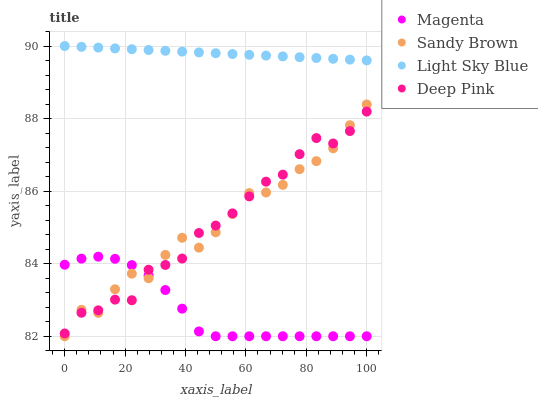Does Magenta have the minimum area under the curve?
Answer yes or no. Yes. Does Light Sky Blue have the maximum area under the curve?
Answer yes or no. Yes. Does Sandy Brown have the minimum area under the curve?
Answer yes or no. No. Does Sandy Brown have the maximum area under the curve?
Answer yes or no. No. Is Light Sky Blue the smoothest?
Answer yes or no. Yes. Is Sandy Brown the roughest?
Answer yes or no. Yes. Is Sandy Brown the smoothest?
Answer yes or no. No. Is Light Sky Blue the roughest?
Answer yes or no. No. Does Magenta have the lowest value?
Answer yes or no. Yes. Does Light Sky Blue have the lowest value?
Answer yes or no. No. Does Light Sky Blue have the highest value?
Answer yes or no. Yes. Does Sandy Brown have the highest value?
Answer yes or no. No. Is Sandy Brown less than Light Sky Blue?
Answer yes or no. Yes. Is Light Sky Blue greater than Sandy Brown?
Answer yes or no. Yes. Does Sandy Brown intersect Deep Pink?
Answer yes or no. Yes. Is Sandy Brown less than Deep Pink?
Answer yes or no. No. Is Sandy Brown greater than Deep Pink?
Answer yes or no. No. Does Sandy Brown intersect Light Sky Blue?
Answer yes or no. No. 